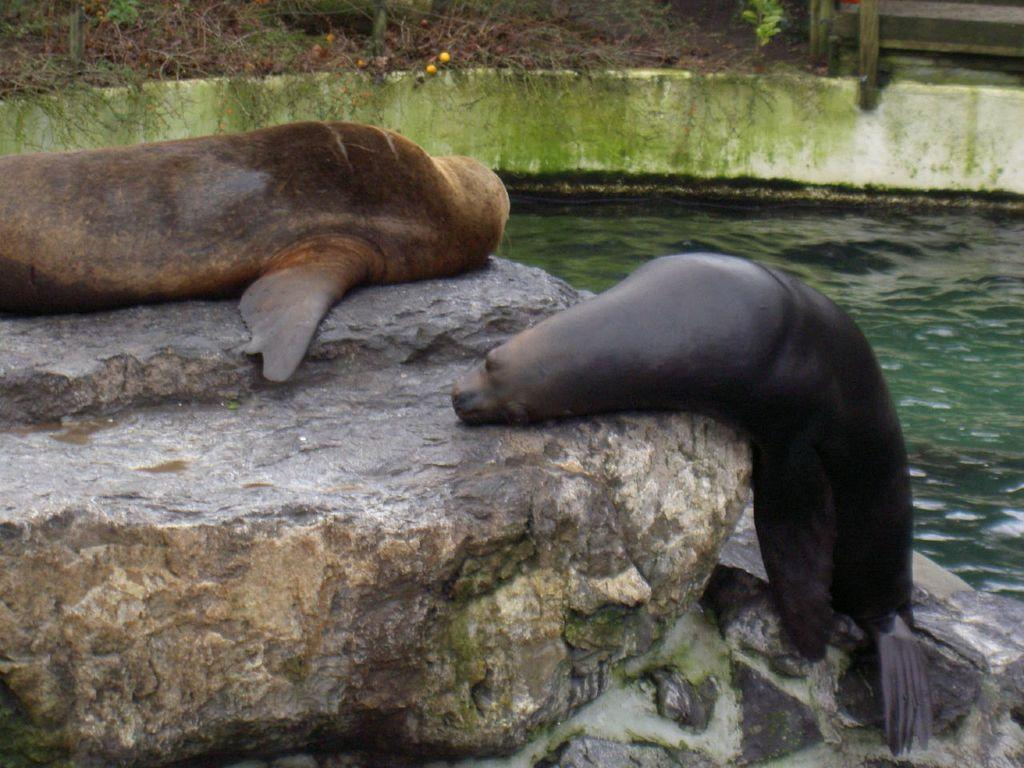What animals are present in the image? There are two sea lions in the image. What are the sea lions doing in the image? The sea lions are lying on a rock. What can be seen on the right side of the image? There is water visible on the right side of the image. What type of clover can be seen growing near the river in the image? There is no river or clover present in the image; it features two sea lions lying on a rock with water visible on the right side. 